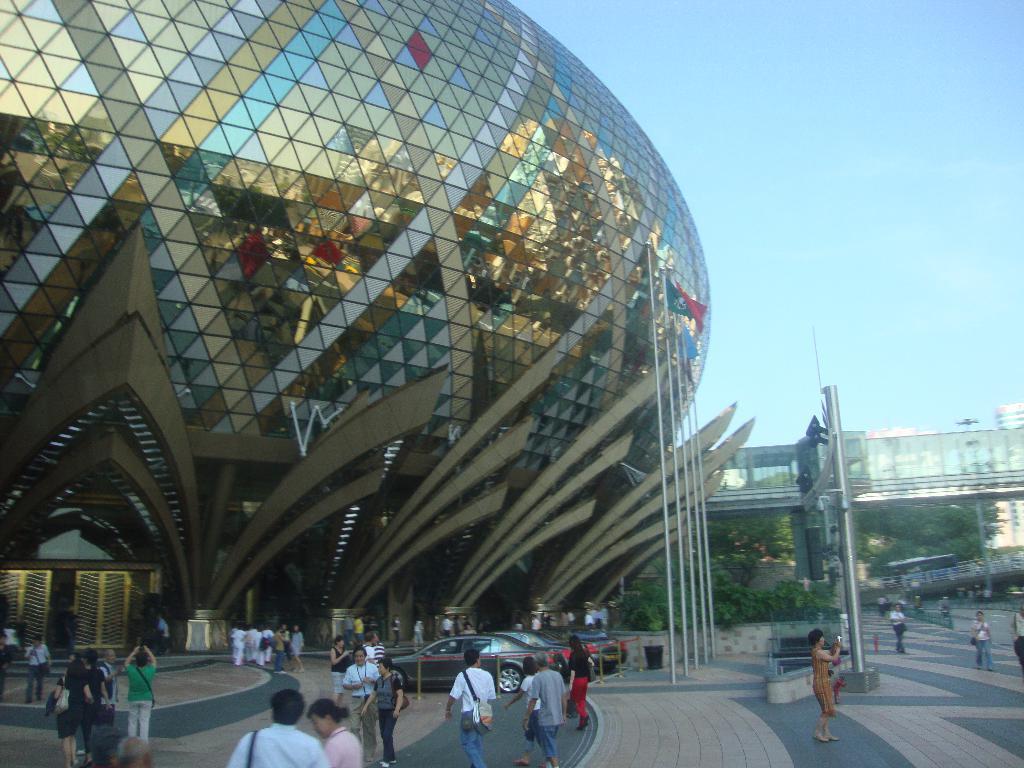Describe this image in one or two sentences. In this image there is an iconic building, in front of the building there are people doing different activities and cars are parked to a side, there are flag poles and a footpath near the building and a road, in the background there is a sky. 